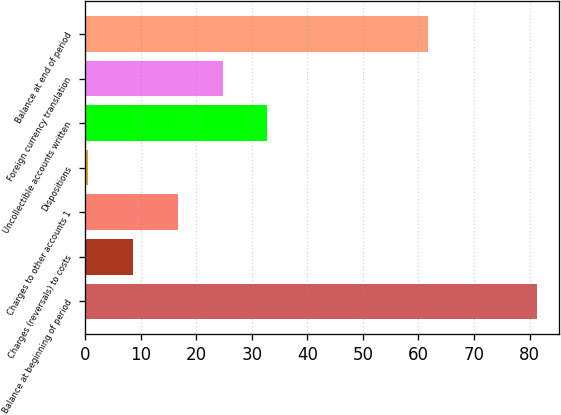Convert chart to OTSL. <chart><loc_0><loc_0><loc_500><loc_500><bar_chart><fcel>Balance at beginning of period<fcel>Charges (reversals) to costs<fcel>Charges to other accounts 1<fcel>Dispositions<fcel>Uncollectible accounts written<fcel>Foreign currency translation<fcel>Balance at end of period<nl><fcel>81.3<fcel>8.58<fcel>16.66<fcel>0.5<fcel>32.82<fcel>24.74<fcel>61.8<nl></chart> 